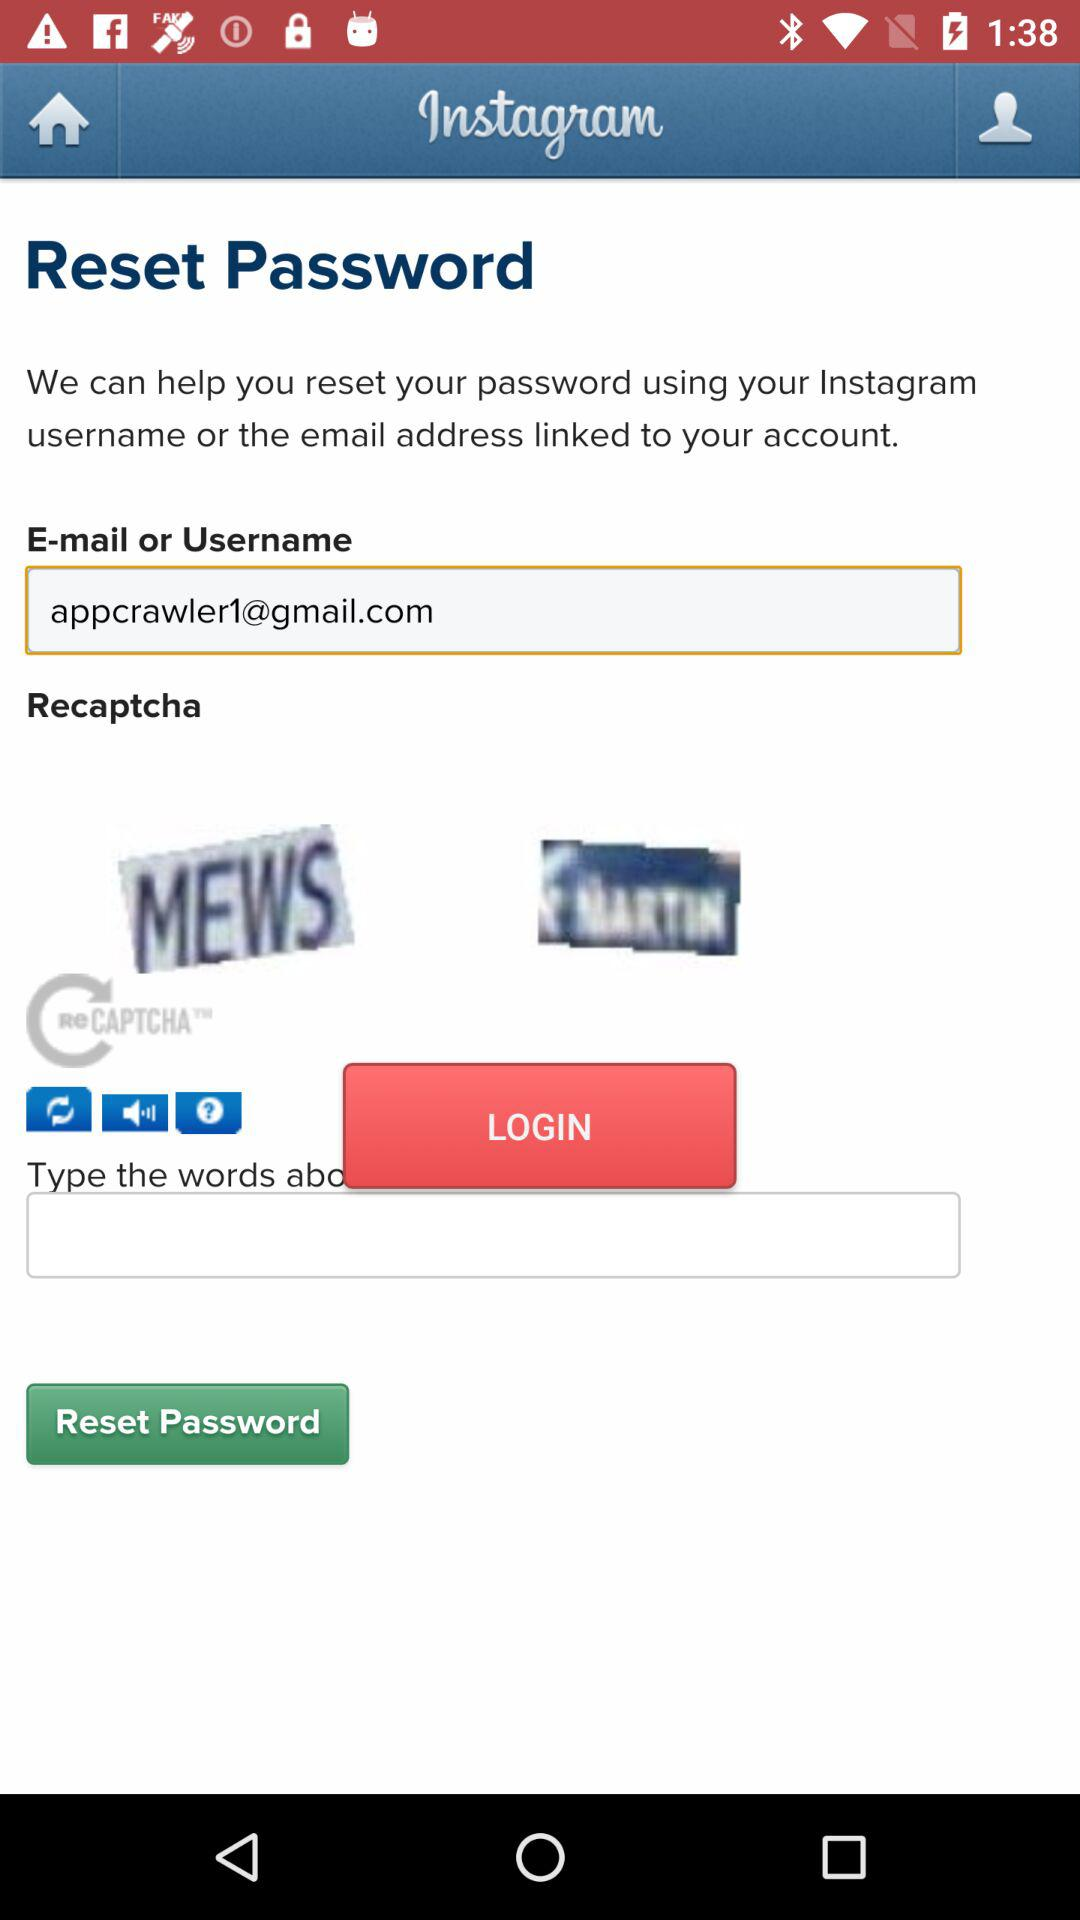What is the captcha code? The captcha codes are "MEWS" and "FMARTIN". 